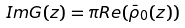Convert formula to latex. <formula><loc_0><loc_0><loc_500><loc_500>I m G ( z ) = \pi R e ( \bar { \rho } _ { 0 } ( z ) )</formula> 